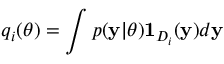<formula> <loc_0><loc_0><loc_500><loc_500>q _ { i } ( \theta ) = \int p ( y | \theta ) 1 _ { D _ { i } } ( y ) d y</formula> 